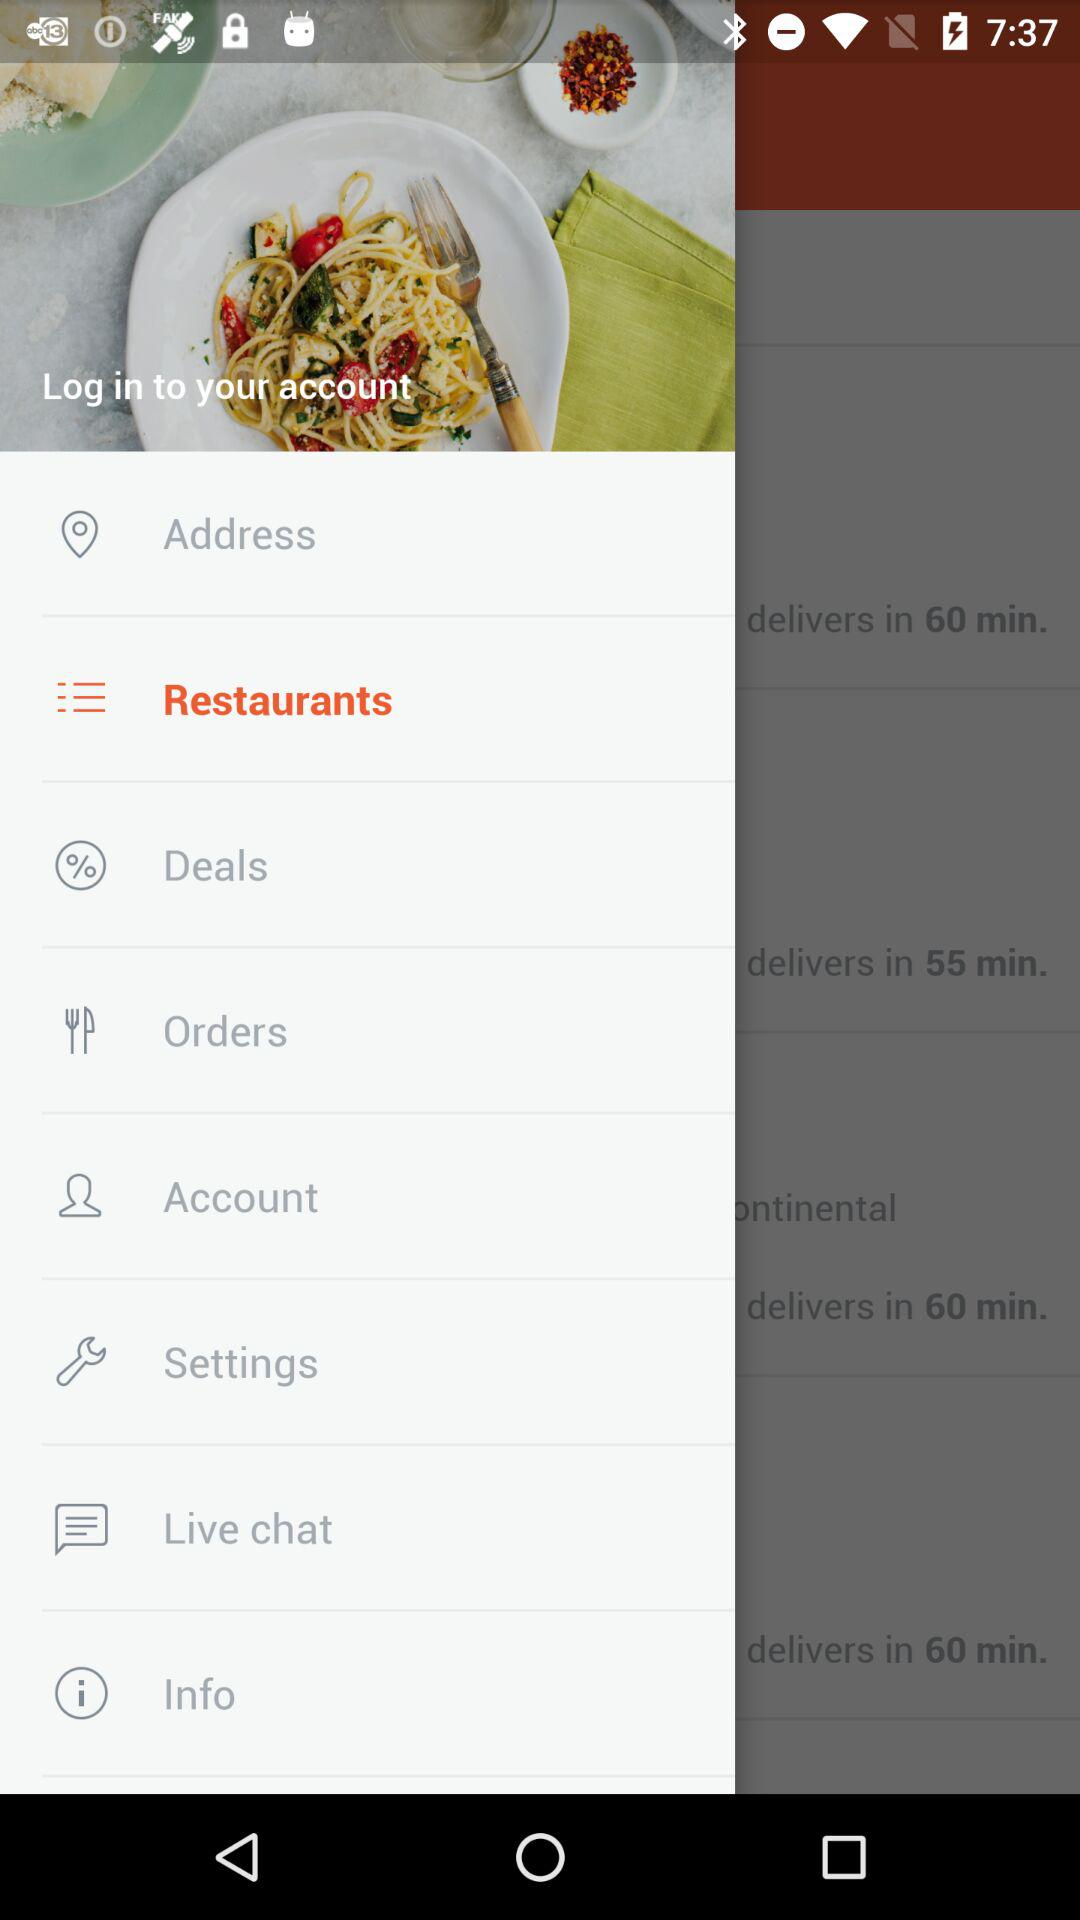Which is the selected item in the menu? The selected item is "Restaurants". 